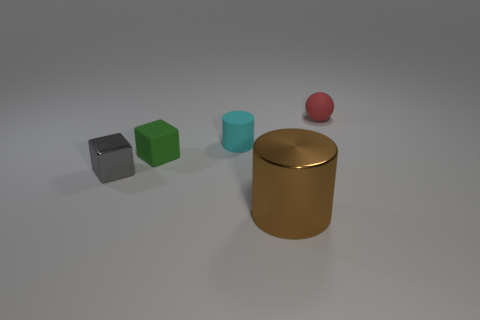Add 4 small yellow rubber cubes. How many objects exist? 9 Subtract all spheres. How many objects are left? 4 Subtract 0 purple balls. How many objects are left? 5 Subtract all gray objects. Subtract all big shiny things. How many objects are left? 3 Add 4 small gray blocks. How many small gray blocks are left? 5 Add 4 cyan matte cylinders. How many cyan matte cylinders exist? 5 